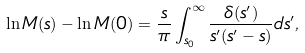<formula> <loc_0><loc_0><loc_500><loc_500>\ln M ( s ) - \ln M ( 0 ) = \frac { s } { \pi } \int _ { s _ { 0 } } ^ { \infty } \frac { \delta ( s ^ { \prime } ) } { s ^ { \prime } ( s ^ { \prime } - s ) } d s ^ { \prime } ,</formula> 